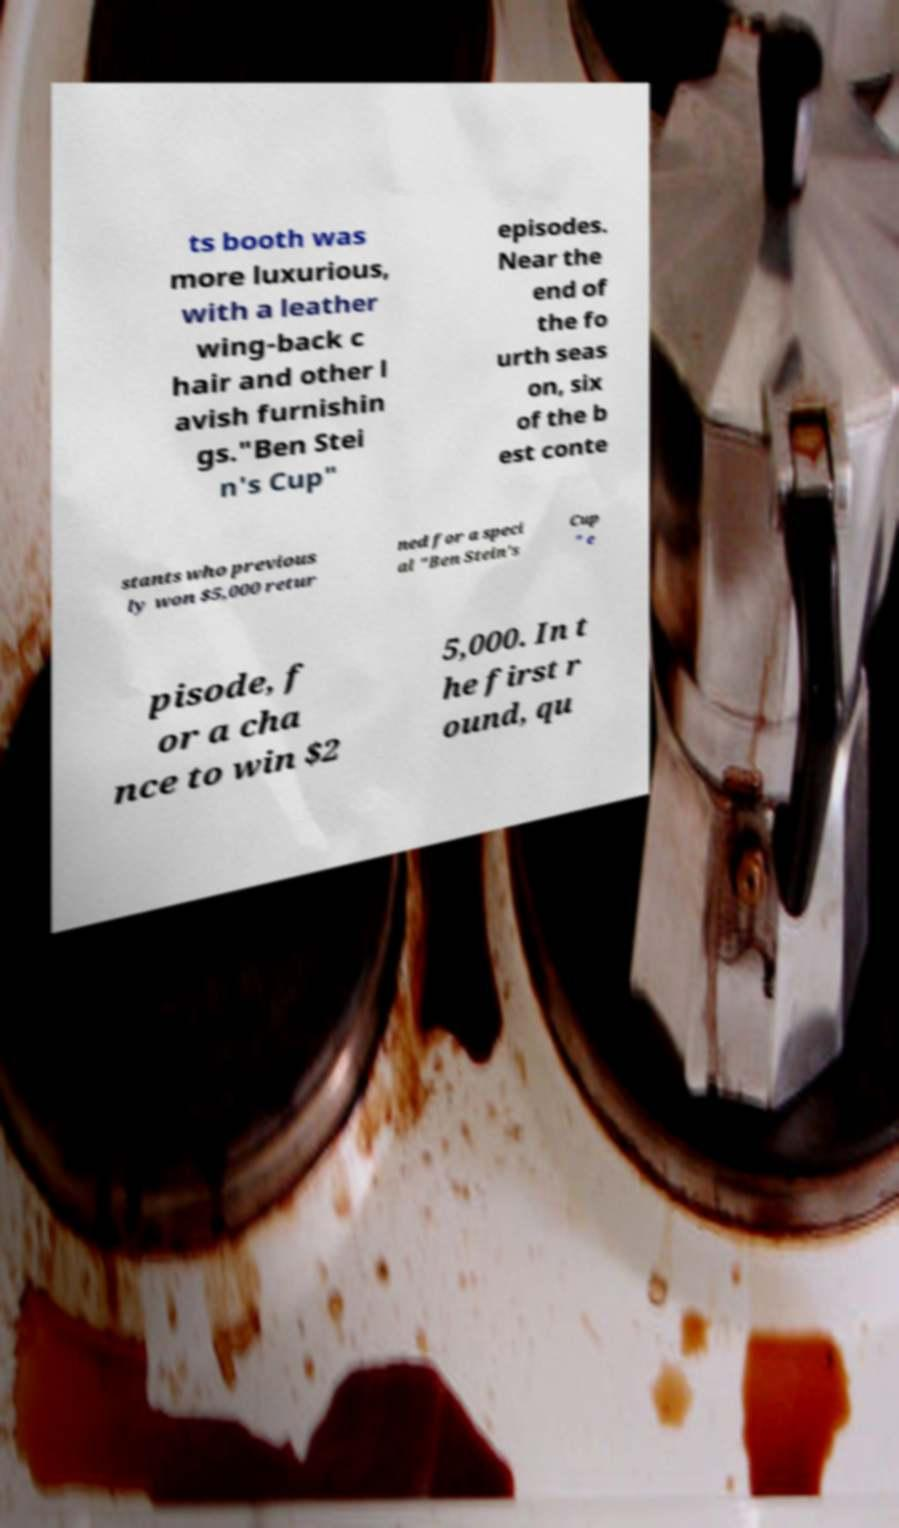I need the written content from this picture converted into text. Can you do that? ts booth was more luxurious, with a leather wing-back c hair and other l avish furnishin gs."Ben Stei n's Cup" episodes. Near the end of the fo urth seas on, six of the b est conte stants who previous ly won $5,000 retur ned for a speci al "Ben Stein's Cup " e pisode, f or a cha nce to win $2 5,000. In t he first r ound, qu 